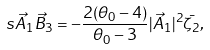<formula> <loc_0><loc_0><loc_500><loc_500>\ s { \vec { A } _ { 1 } } { \vec { B } _ { 3 } } = - \frac { 2 ( \theta _ { 0 } - 4 ) } { \theta _ { 0 } - 3 } | \vec { A } _ { 1 } | ^ { 2 } \bar { \zeta _ { 2 } } ,</formula> 